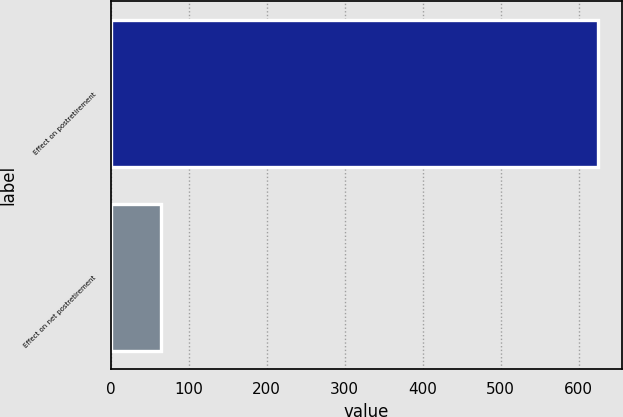<chart> <loc_0><loc_0><loc_500><loc_500><bar_chart><fcel>Effect on postretirement<fcel>Effect on net postretirement<nl><fcel>624<fcel>65<nl></chart> 